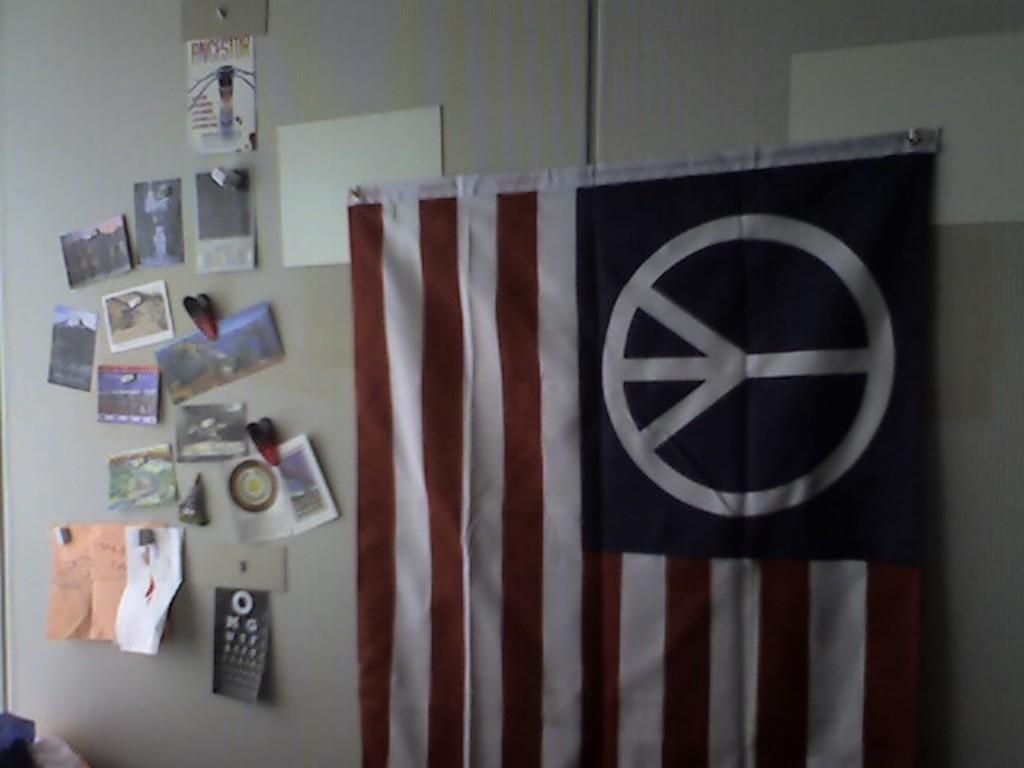Could you give a brief overview of what you see in this image? In this image there is a flag, few photos and posters are pinned to the wall. 